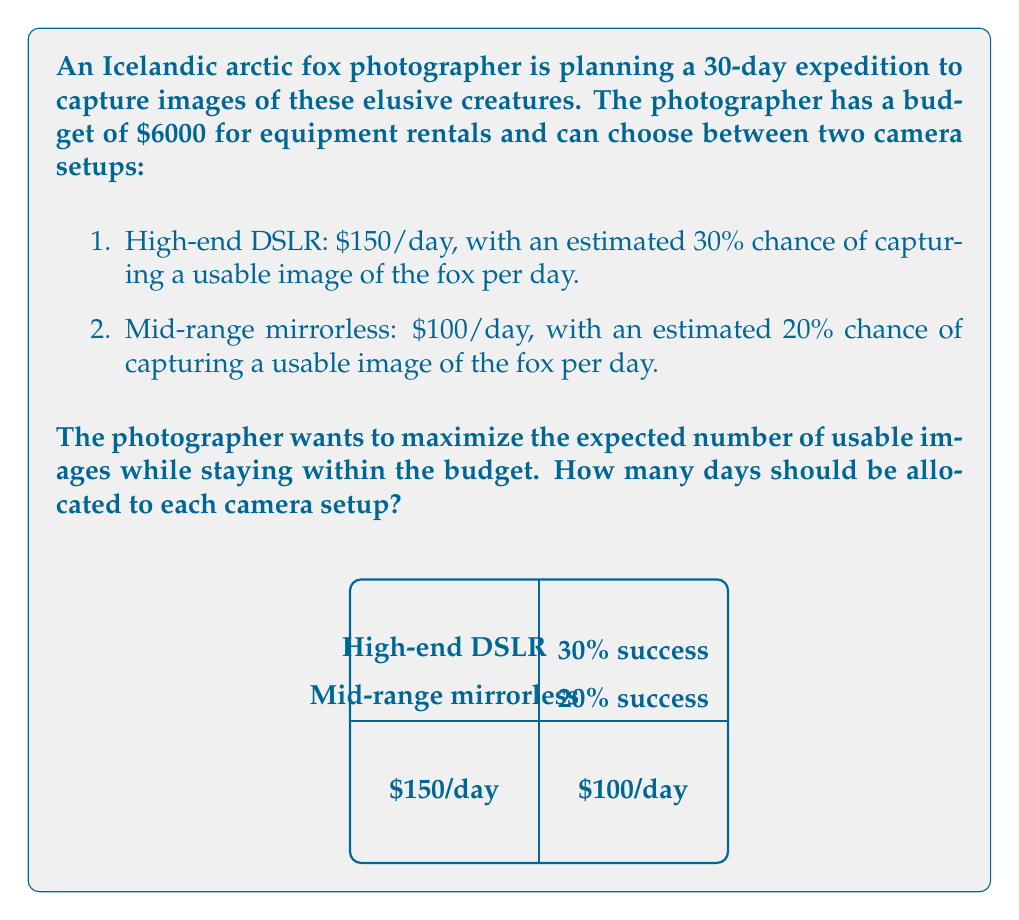Can you solve this math problem? Let's approach this problem step-by-step using linear programming:

1) Define variables:
   Let $x$ = number of days with high-end DSLR
   Let $y$ = number of days with mid-range mirrorless

2) Objective function:
   Maximize $Z = 0.3x + 0.2y$ (expected number of usable images)

3) Constraints:
   Budget constraint: $150x + 100y \leq 6000$
   Time constraint: $x + y \leq 30$
   Non-negativity: $x \geq 0, y \geq 0$

4) Simplify the budget constraint:
   $3x + 2y \leq 120$

5) Graph the constraints:
   $3x + 2y = 120$ intersects axes at (40,0) and (0,60)
   $x + y = 30$ intersects axes at (30,0) and (0,30)

6) The feasible region is bounded by these lines and the axes.

7) Optimal solution will be at one of the corner points:
   (0,0), (30,0), (0,30), and the intersection of $3x + 2y = 120$ and $x + y = 30$

8) Find the intersection point:
   $3x + 2y = 120$
   $x + y = 30$
   Subtracting: $2x + y = 90$
   $y = 90 - 2x$
   Substituting into $x + y = 30$:
   $x + (90 - 2x) = 30$
   $90 - x = 30$
   $x = 60$
   $y = -30$ (infeasible)

9) Evaluate $Z$ at feasible corner points:
   (0,0): $Z = 0$
   (30,0): $Z = 9$
   (0,30): $Z = 6$

10) The optimal solution is (30,0), meaning all 30 days should be allocated to the high-end DSLR.
Answer: 30 days with high-end DSLR, 0 days with mid-range mirrorless 